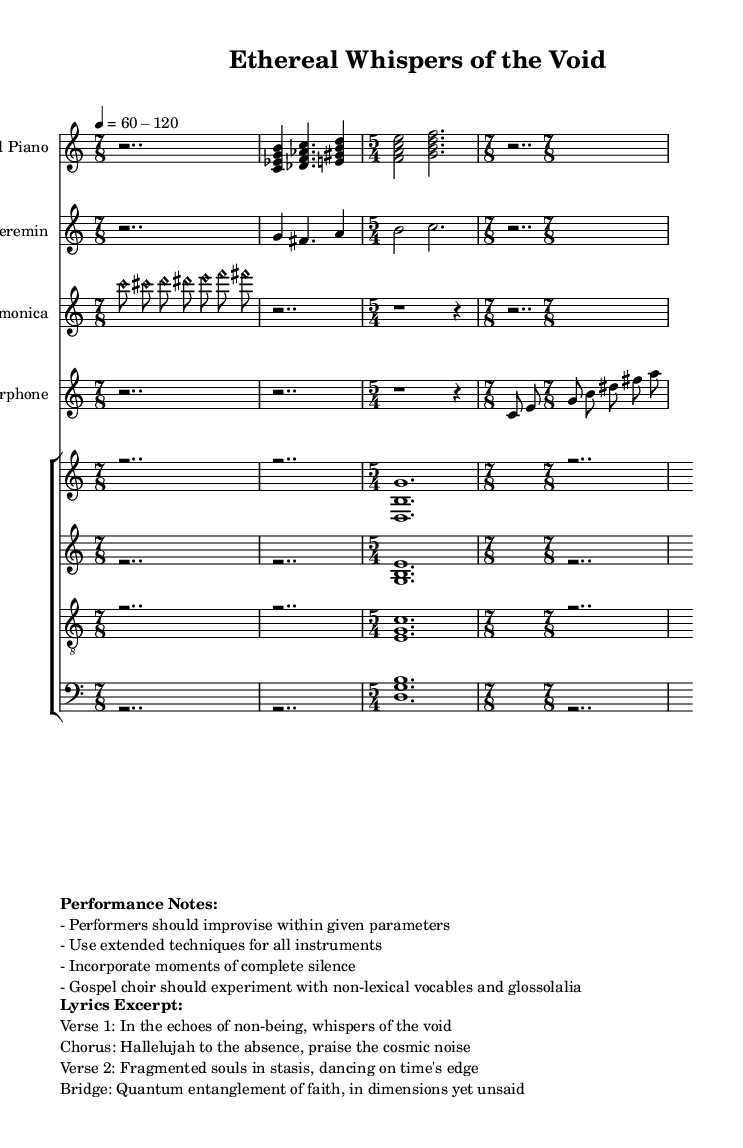What is the time signature of the piece? The time signature is prominently displayed at the beginning. Here, it is indicated as 7/8, and this is seen before the first staff culminates into different time signatures like 5/4 and 7/8 throughout the sheet.
Answer: 7/8 What is the tempo marking given in the score? The tempo marking is provided near the beginning of the score. It indicates a range from 60 to 120 beats per minute, suggesting the speed of the piece can vary within this range.
Answer: 60-120 How many different instruments are featured in the piece? By counting the distinct staff labels in the score, such as 'Prepared Piano', 'Theremin', 'Glass Harmonica', 'Waterphone', and 'Choir', I conclude there are five unique instruments used.
Answer: 5 What is the first line of the lyrics in the excerpt? The lyrics excerpt is placed prominently towards the end of the score. The first line of the verse is clearly stated as "In the echoes of non-being, whispers of the void."
Answer: In the echoes of non-being, whispers of the void What vocal techniques are suggested for the gospel choir? The performance notes mention specific techniques for the choir, suggesting they should experiment with non-lexical vocables and glossolalia. This indicates the need for unconventional singing methods.
Answer: non-lexical vocables and glossolalia What extended technique is mentioned for the instrumentalists? The performance notes indicate that performers should utilize extended techniques for all instruments. This refers to playing methods that go beyond the traditional use of each instrument.
Answer: extended techniques How many vocal parts are included in the choir? The choir section of the score displays four distinct vocal parts: soprano, alto, tenor, and bass. Counting these gives the answer that there are four different vocal parts represented.
Answer: 4 